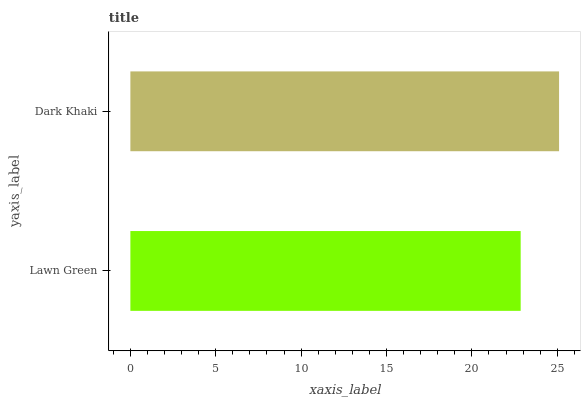Is Lawn Green the minimum?
Answer yes or no. Yes. Is Dark Khaki the maximum?
Answer yes or no. Yes. Is Dark Khaki the minimum?
Answer yes or no. No. Is Dark Khaki greater than Lawn Green?
Answer yes or no. Yes. Is Lawn Green less than Dark Khaki?
Answer yes or no. Yes. Is Lawn Green greater than Dark Khaki?
Answer yes or no. No. Is Dark Khaki less than Lawn Green?
Answer yes or no. No. Is Dark Khaki the high median?
Answer yes or no. Yes. Is Lawn Green the low median?
Answer yes or no. Yes. Is Lawn Green the high median?
Answer yes or no. No. Is Dark Khaki the low median?
Answer yes or no. No. 